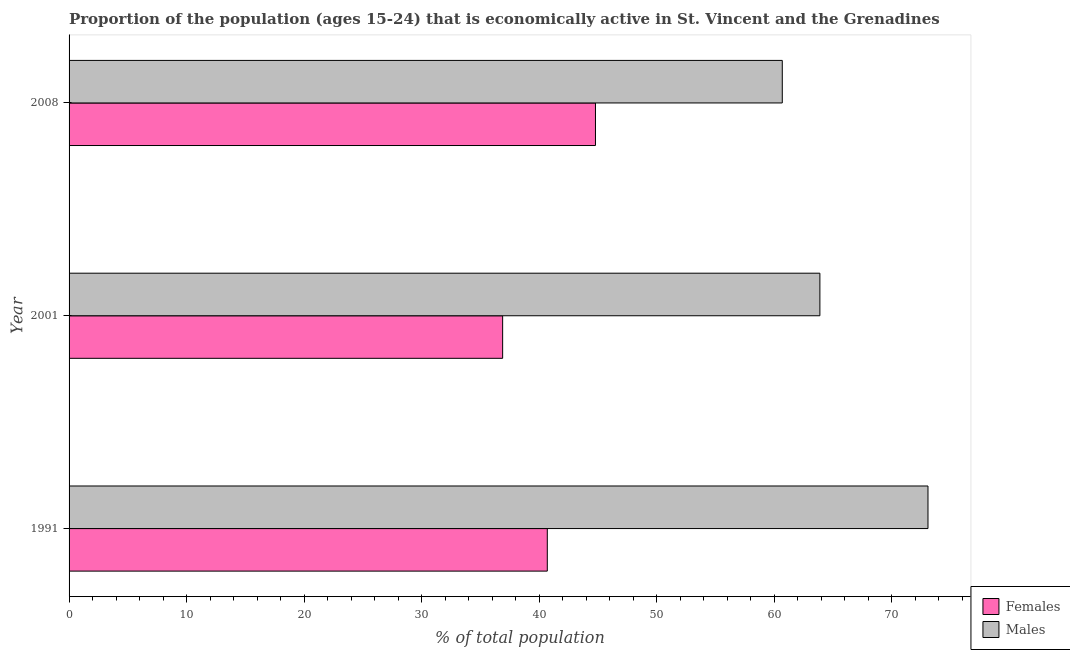How many different coloured bars are there?
Your response must be concise. 2. Are the number of bars per tick equal to the number of legend labels?
Give a very brief answer. Yes. How many bars are there on the 2nd tick from the top?
Give a very brief answer. 2. In how many cases, is the number of bars for a given year not equal to the number of legend labels?
Make the answer very short. 0. What is the percentage of economically active male population in 2008?
Give a very brief answer. 60.7. Across all years, what is the maximum percentage of economically active male population?
Your answer should be very brief. 73.1. Across all years, what is the minimum percentage of economically active female population?
Give a very brief answer. 36.9. What is the total percentage of economically active male population in the graph?
Provide a succinct answer. 197.7. What is the average percentage of economically active male population per year?
Offer a very short reply. 65.9. In the year 1991, what is the difference between the percentage of economically active female population and percentage of economically active male population?
Your answer should be compact. -32.4. In how many years, is the percentage of economically active male population greater than 42 %?
Give a very brief answer. 3. What is the ratio of the percentage of economically active male population in 2001 to that in 2008?
Offer a very short reply. 1.05. Is the percentage of economically active female population in 2001 less than that in 2008?
Keep it short and to the point. Yes. Is the difference between the percentage of economically active male population in 2001 and 2008 greater than the difference between the percentage of economically active female population in 2001 and 2008?
Ensure brevity in your answer.  Yes. What is the difference between the highest and the lowest percentage of economically active female population?
Provide a succinct answer. 7.9. Is the sum of the percentage of economically active male population in 1991 and 2008 greater than the maximum percentage of economically active female population across all years?
Offer a very short reply. Yes. What does the 2nd bar from the top in 2001 represents?
Your answer should be compact. Females. What does the 1st bar from the bottom in 2001 represents?
Keep it short and to the point. Females. Are all the bars in the graph horizontal?
Provide a succinct answer. Yes. How many years are there in the graph?
Offer a very short reply. 3. What is the difference between two consecutive major ticks on the X-axis?
Offer a terse response. 10. Does the graph contain any zero values?
Your response must be concise. No. Does the graph contain grids?
Make the answer very short. No. Where does the legend appear in the graph?
Your answer should be very brief. Bottom right. How many legend labels are there?
Provide a short and direct response. 2. How are the legend labels stacked?
Offer a very short reply. Vertical. What is the title of the graph?
Your answer should be very brief. Proportion of the population (ages 15-24) that is economically active in St. Vincent and the Grenadines. What is the label or title of the X-axis?
Make the answer very short. % of total population. What is the label or title of the Y-axis?
Offer a very short reply. Year. What is the % of total population of Females in 1991?
Ensure brevity in your answer.  40.7. What is the % of total population of Males in 1991?
Your response must be concise. 73.1. What is the % of total population of Females in 2001?
Make the answer very short. 36.9. What is the % of total population in Males in 2001?
Your response must be concise. 63.9. What is the % of total population in Females in 2008?
Give a very brief answer. 44.8. What is the % of total population in Males in 2008?
Provide a succinct answer. 60.7. Across all years, what is the maximum % of total population of Females?
Offer a very short reply. 44.8. Across all years, what is the maximum % of total population in Males?
Your response must be concise. 73.1. Across all years, what is the minimum % of total population of Females?
Keep it short and to the point. 36.9. Across all years, what is the minimum % of total population in Males?
Ensure brevity in your answer.  60.7. What is the total % of total population in Females in the graph?
Your response must be concise. 122.4. What is the total % of total population in Males in the graph?
Your answer should be very brief. 197.7. What is the difference between the % of total population of Females in 1991 and that in 2001?
Keep it short and to the point. 3.8. What is the difference between the % of total population in Females in 1991 and that in 2008?
Your answer should be compact. -4.1. What is the difference between the % of total population in Females in 1991 and the % of total population in Males in 2001?
Offer a very short reply. -23.2. What is the difference between the % of total population of Females in 1991 and the % of total population of Males in 2008?
Provide a succinct answer. -20. What is the difference between the % of total population of Females in 2001 and the % of total population of Males in 2008?
Provide a short and direct response. -23.8. What is the average % of total population in Females per year?
Keep it short and to the point. 40.8. What is the average % of total population of Males per year?
Your answer should be compact. 65.9. In the year 1991, what is the difference between the % of total population of Females and % of total population of Males?
Your answer should be very brief. -32.4. In the year 2001, what is the difference between the % of total population of Females and % of total population of Males?
Offer a very short reply. -27. In the year 2008, what is the difference between the % of total population in Females and % of total population in Males?
Your response must be concise. -15.9. What is the ratio of the % of total population in Females in 1991 to that in 2001?
Provide a short and direct response. 1.1. What is the ratio of the % of total population of Males in 1991 to that in 2001?
Ensure brevity in your answer.  1.14. What is the ratio of the % of total population of Females in 1991 to that in 2008?
Ensure brevity in your answer.  0.91. What is the ratio of the % of total population of Males in 1991 to that in 2008?
Offer a very short reply. 1.2. What is the ratio of the % of total population in Females in 2001 to that in 2008?
Keep it short and to the point. 0.82. What is the ratio of the % of total population of Males in 2001 to that in 2008?
Give a very brief answer. 1.05. What is the difference between the highest and the lowest % of total population of Males?
Your response must be concise. 12.4. 